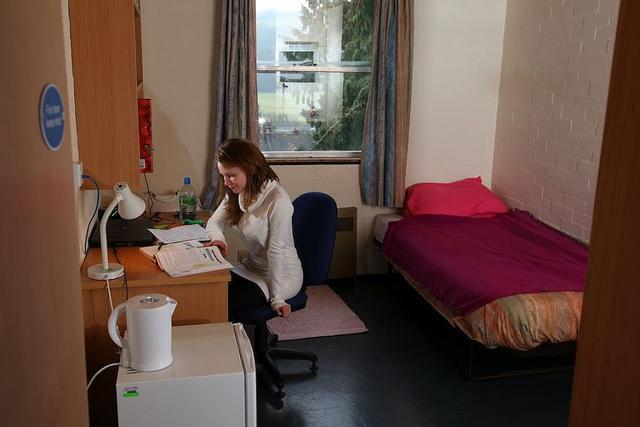How many books are visible?
Give a very brief answer. 1. How many people are visible?
Give a very brief answer. 1. How many elephant are facing the right side of the image?
Give a very brief answer. 0. 